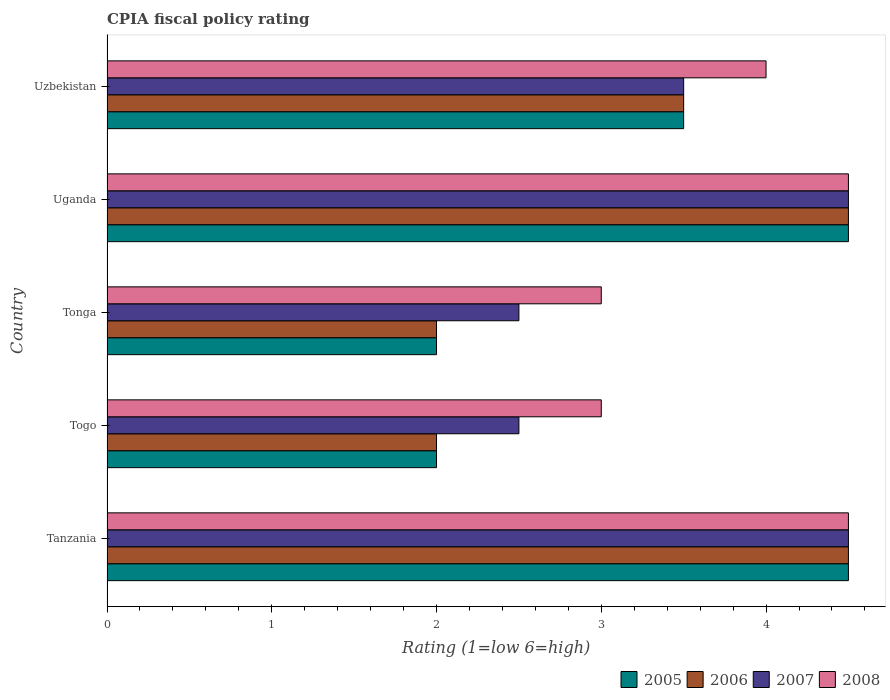How many different coloured bars are there?
Your answer should be very brief. 4. How many groups of bars are there?
Give a very brief answer. 5. Are the number of bars on each tick of the Y-axis equal?
Give a very brief answer. Yes. How many bars are there on the 1st tick from the bottom?
Give a very brief answer. 4. What is the label of the 3rd group of bars from the top?
Offer a terse response. Tonga. In how many cases, is the number of bars for a given country not equal to the number of legend labels?
Ensure brevity in your answer.  0. What is the CPIA rating in 2005 in Tonga?
Keep it short and to the point. 2. In which country was the CPIA rating in 2008 maximum?
Your answer should be very brief. Tanzania. In which country was the CPIA rating in 2008 minimum?
Keep it short and to the point. Togo. What is the average CPIA rating in 2006 per country?
Ensure brevity in your answer.  3.3. What is the difference between the CPIA rating in 2006 and CPIA rating in 2005 in Tanzania?
Offer a very short reply. 0. What is the ratio of the CPIA rating in 2005 in Tanzania to that in Uganda?
Provide a succinct answer. 1. Is the CPIA rating in 2008 in Tonga less than that in Uganda?
Offer a very short reply. Yes. Is the difference between the CPIA rating in 2006 in Togo and Uganda greater than the difference between the CPIA rating in 2005 in Togo and Uganda?
Your response must be concise. No. What is the difference between the highest and the second highest CPIA rating in 2008?
Offer a very short reply. 0. What is the difference between the highest and the lowest CPIA rating in 2006?
Make the answer very short. 2.5. Is it the case that in every country, the sum of the CPIA rating in 2005 and CPIA rating in 2008 is greater than the sum of CPIA rating in 2007 and CPIA rating in 2006?
Keep it short and to the point. No. What does the 1st bar from the top in Uganda represents?
Offer a terse response. 2008. Is it the case that in every country, the sum of the CPIA rating in 2007 and CPIA rating in 2006 is greater than the CPIA rating in 2005?
Your response must be concise. Yes. Where does the legend appear in the graph?
Ensure brevity in your answer.  Bottom right. How many legend labels are there?
Your response must be concise. 4. How are the legend labels stacked?
Make the answer very short. Horizontal. What is the title of the graph?
Make the answer very short. CPIA fiscal policy rating. Does "1992" appear as one of the legend labels in the graph?
Offer a terse response. No. What is the label or title of the Y-axis?
Make the answer very short. Country. What is the Rating (1=low 6=high) in 2005 in Tanzania?
Make the answer very short. 4.5. What is the Rating (1=low 6=high) in 2008 in Tanzania?
Offer a very short reply. 4.5. What is the Rating (1=low 6=high) of 2005 in Togo?
Your response must be concise. 2. What is the Rating (1=low 6=high) of 2006 in Togo?
Your response must be concise. 2. What is the Rating (1=low 6=high) in 2007 in Togo?
Your response must be concise. 2.5. What is the Rating (1=low 6=high) of 2005 in Tonga?
Give a very brief answer. 2. What is the Rating (1=low 6=high) of 2006 in Tonga?
Keep it short and to the point. 2. What is the Rating (1=low 6=high) in 2007 in Tonga?
Your response must be concise. 2.5. What is the Rating (1=low 6=high) of 2008 in Tonga?
Provide a short and direct response. 3. What is the Rating (1=low 6=high) of 2007 in Uganda?
Ensure brevity in your answer.  4.5. What is the Rating (1=low 6=high) of 2005 in Uzbekistan?
Your answer should be compact. 3.5. What is the Rating (1=low 6=high) in 2007 in Uzbekistan?
Your answer should be compact. 3.5. What is the Rating (1=low 6=high) in 2008 in Uzbekistan?
Ensure brevity in your answer.  4. Across all countries, what is the maximum Rating (1=low 6=high) of 2005?
Ensure brevity in your answer.  4.5. Across all countries, what is the maximum Rating (1=low 6=high) in 2006?
Give a very brief answer. 4.5. Across all countries, what is the maximum Rating (1=low 6=high) of 2008?
Ensure brevity in your answer.  4.5. Across all countries, what is the minimum Rating (1=low 6=high) in 2007?
Provide a succinct answer. 2.5. What is the total Rating (1=low 6=high) of 2005 in the graph?
Make the answer very short. 16.5. What is the total Rating (1=low 6=high) in 2008 in the graph?
Provide a succinct answer. 19. What is the difference between the Rating (1=low 6=high) in 2005 in Tanzania and that in Togo?
Provide a short and direct response. 2.5. What is the difference between the Rating (1=low 6=high) in 2007 in Tanzania and that in Togo?
Your answer should be very brief. 2. What is the difference between the Rating (1=low 6=high) of 2006 in Tanzania and that in Uganda?
Offer a very short reply. 0. What is the difference between the Rating (1=low 6=high) in 2005 in Tanzania and that in Uzbekistan?
Offer a very short reply. 1. What is the difference between the Rating (1=low 6=high) of 2005 in Togo and that in Tonga?
Give a very brief answer. 0. What is the difference between the Rating (1=low 6=high) of 2006 in Togo and that in Tonga?
Ensure brevity in your answer.  0. What is the difference between the Rating (1=low 6=high) of 2007 in Togo and that in Tonga?
Make the answer very short. 0. What is the difference between the Rating (1=low 6=high) of 2005 in Togo and that in Uganda?
Offer a very short reply. -2.5. What is the difference between the Rating (1=low 6=high) in 2006 in Togo and that in Uganda?
Give a very brief answer. -2.5. What is the difference between the Rating (1=low 6=high) of 2005 in Togo and that in Uzbekistan?
Your answer should be very brief. -1.5. What is the difference between the Rating (1=low 6=high) of 2006 in Togo and that in Uzbekistan?
Ensure brevity in your answer.  -1.5. What is the difference between the Rating (1=low 6=high) in 2006 in Tonga and that in Uganda?
Your answer should be compact. -2.5. What is the difference between the Rating (1=low 6=high) of 2007 in Tonga and that in Uganda?
Your answer should be very brief. -2. What is the difference between the Rating (1=low 6=high) of 2005 in Tonga and that in Uzbekistan?
Make the answer very short. -1.5. What is the difference between the Rating (1=low 6=high) in 2006 in Tonga and that in Uzbekistan?
Give a very brief answer. -1.5. What is the difference between the Rating (1=low 6=high) of 2005 in Tanzania and the Rating (1=low 6=high) of 2008 in Togo?
Offer a very short reply. 1.5. What is the difference between the Rating (1=low 6=high) of 2006 in Tanzania and the Rating (1=low 6=high) of 2007 in Togo?
Offer a very short reply. 2. What is the difference between the Rating (1=low 6=high) of 2006 in Tanzania and the Rating (1=low 6=high) of 2008 in Togo?
Keep it short and to the point. 1.5. What is the difference between the Rating (1=low 6=high) of 2005 in Tanzania and the Rating (1=low 6=high) of 2006 in Tonga?
Offer a terse response. 2.5. What is the difference between the Rating (1=low 6=high) of 2005 in Tanzania and the Rating (1=low 6=high) of 2008 in Tonga?
Provide a succinct answer. 1.5. What is the difference between the Rating (1=low 6=high) of 2006 in Tanzania and the Rating (1=low 6=high) of 2008 in Tonga?
Keep it short and to the point. 1.5. What is the difference between the Rating (1=low 6=high) of 2007 in Tanzania and the Rating (1=low 6=high) of 2008 in Tonga?
Make the answer very short. 1.5. What is the difference between the Rating (1=low 6=high) in 2005 in Tanzania and the Rating (1=low 6=high) in 2007 in Uganda?
Your response must be concise. 0. What is the difference between the Rating (1=low 6=high) in 2005 in Tanzania and the Rating (1=low 6=high) in 2008 in Uganda?
Give a very brief answer. 0. What is the difference between the Rating (1=low 6=high) in 2006 in Tanzania and the Rating (1=low 6=high) in 2007 in Uganda?
Make the answer very short. 0. What is the difference between the Rating (1=low 6=high) of 2006 in Tanzania and the Rating (1=low 6=high) of 2008 in Uganda?
Ensure brevity in your answer.  0. What is the difference between the Rating (1=low 6=high) of 2007 in Tanzania and the Rating (1=low 6=high) of 2008 in Uganda?
Provide a short and direct response. 0. What is the difference between the Rating (1=low 6=high) of 2005 in Tanzania and the Rating (1=low 6=high) of 2006 in Uzbekistan?
Your answer should be compact. 1. What is the difference between the Rating (1=low 6=high) in 2006 in Tanzania and the Rating (1=low 6=high) in 2008 in Uzbekistan?
Provide a short and direct response. 0.5. What is the difference between the Rating (1=low 6=high) in 2007 in Tanzania and the Rating (1=low 6=high) in 2008 in Uzbekistan?
Make the answer very short. 0.5. What is the difference between the Rating (1=low 6=high) of 2005 in Togo and the Rating (1=low 6=high) of 2006 in Tonga?
Your answer should be compact. 0. What is the difference between the Rating (1=low 6=high) in 2005 in Togo and the Rating (1=low 6=high) in 2007 in Tonga?
Make the answer very short. -0.5. What is the difference between the Rating (1=low 6=high) of 2005 in Togo and the Rating (1=low 6=high) of 2007 in Uganda?
Offer a very short reply. -2.5. What is the difference between the Rating (1=low 6=high) in 2005 in Togo and the Rating (1=low 6=high) in 2008 in Uganda?
Offer a very short reply. -2.5. What is the difference between the Rating (1=low 6=high) of 2006 in Togo and the Rating (1=low 6=high) of 2008 in Uganda?
Offer a very short reply. -2.5. What is the difference between the Rating (1=low 6=high) in 2007 in Togo and the Rating (1=low 6=high) in 2008 in Uganda?
Give a very brief answer. -2. What is the difference between the Rating (1=low 6=high) in 2005 in Togo and the Rating (1=low 6=high) in 2007 in Uzbekistan?
Make the answer very short. -1.5. What is the difference between the Rating (1=low 6=high) of 2007 in Togo and the Rating (1=low 6=high) of 2008 in Uzbekistan?
Your answer should be very brief. -1.5. What is the difference between the Rating (1=low 6=high) in 2005 in Tonga and the Rating (1=low 6=high) in 2007 in Uganda?
Make the answer very short. -2.5. What is the difference between the Rating (1=low 6=high) of 2005 in Tonga and the Rating (1=low 6=high) of 2008 in Uganda?
Keep it short and to the point. -2.5. What is the difference between the Rating (1=low 6=high) of 2006 in Tonga and the Rating (1=low 6=high) of 2007 in Uganda?
Ensure brevity in your answer.  -2.5. What is the difference between the Rating (1=low 6=high) of 2007 in Tonga and the Rating (1=low 6=high) of 2008 in Uganda?
Make the answer very short. -2. What is the difference between the Rating (1=low 6=high) of 2005 in Tonga and the Rating (1=low 6=high) of 2006 in Uzbekistan?
Provide a succinct answer. -1.5. What is the difference between the Rating (1=low 6=high) of 2006 in Tonga and the Rating (1=low 6=high) of 2008 in Uzbekistan?
Keep it short and to the point. -2. What is the difference between the Rating (1=low 6=high) of 2006 in Uganda and the Rating (1=low 6=high) of 2008 in Uzbekistan?
Your answer should be compact. 0.5. What is the average Rating (1=low 6=high) in 2005 per country?
Your response must be concise. 3.3. What is the average Rating (1=low 6=high) of 2007 per country?
Offer a terse response. 3.5. What is the average Rating (1=low 6=high) in 2008 per country?
Ensure brevity in your answer.  3.8. What is the difference between the Rating (1=low 6=high) of 2006 and Rating (1=low 6=high) of 2008 in Tanzania?
Your answer should be compact. 0. What is the difference between the Rating (1=low 6=high) in 2007 and Rating (1=low 6=high) in 2008 in Tanzania?
Offer a terse response. 0. What is the difference between the Rating (1=low 6=high) of 2005 and Rating (1=low 6=high) of 2006 in Togo?
Keep it short and to the point. 0. What is the difference between the Rating (1=low 6=high) of 2005 and Rating (1=low 6=high) of 2008 in Togo?
Give a very brief answer. -1. What is the difference between the Rating (1=low 6=high) of 2006 and Rating (1=low 6=high) of 2008 in Togo?
Keep it short and to the point. -1. What is the difference between the Rating (1=low 6=high) in 2007 and Rating (1=low 6=high) in 2008 in Togo?
Your answer should be compact. -0.5. What is the difference between the Rating (1=low 6=high) in 2005 and Rating (1=low 6=high) in 2007 in Tonga?
Offer a terse response. -0.5. What is the difference between the Rating (1=low 6=high) of 2006 and Rating (1=low 6=high) of 2008 in Tonga?
Offer a terse response. -1. What is the difference between the Rating (1=low 6=high) of 2007 and Rating (1=low 6=high) of 2008 in Tonga?
Keep it short and to the point. -0.5. What is the difference between the Rating (1=low 6=high) in 2005 and Rating (1=low 6=high) in 2007 in Uganda?
Offer a terse response. 0. What is the difference between the Rating (1=low 6=high) in 2006 and Rating (1=low 6=high) in 2008 in Uganda?
Make the answer very short. 0. What is the difference between the Rating (1=low 6=high) in 2007 and Rating (1=low 6=high) in 2008 in Uganda?
Give a very brief answer. 0. What is the difference between the Rating (1=low 6=high) of 2005 and Rating (1=low 6=high) of 2006 in Uzbekistan?
Your answer should be very brief. 0. What is the difference between the Rating (1=low 6=high) of 2005 and Rating (1=low 6=high) of 2008 in Uzbekistan?
Your answer should be very brief. -0.5. What is the difference between the Rating (1=low 6=high) of 2006 and Rating (1=low 6=high) of 2008 in Uzbekistan?
Provide a succinct answer. -0.5. What is the difference between the Rating (1=low 6=high) of 2007 and Rating (1=low 6=high) of 2008 in Uzbekistan?
Your answer should be very brief. -0.5. What is the ratio of the Rating (1=low 6=high) in 2005 in Tanzania to that in Togo?
Your response must be concise. 2.25. What is the ratio of the Rating (1=low 6=high) of 2006 in Tanzania to that in Togo?
Your answer should be compact. 2.25. What is the ratio of the Rating (1=low 6=high) in 2008 in Tanzania to that in Togo?
Make the answer very short. 1.5. What is the ratio of the Rating (1=low 6=high) of 2005 in Tanzania to that in Tonga?
Make the answer very short. 2.25. What is the ratio of the Rating (1=low 6=high) in 2006 in Tanzania to that in Tonga?
Your response must be concise. 2.25. What is the ratio of the Rating (1=low 6=high) in 2007 in Tanzania to that in Tonga?
Provide a succinct answer. 1.8. What is the ratio of the Rating (1=low 6=high) of 2008 in Tanzania to that in Tonga?
Keep it short and to the point. 1.5. What is the ratio of the Rating (1=low 6=high) of 2006 in Tanzania to that in Uganda?
Offer a terse response. 1. What is the ratio of the Rating (1=low 6=high) of 2007 in Tanzania to that in Uganda?
Your answer should be very brief. 1. What is the ratio of the Rating (1=low 6=high) in 2006 in Tanzania to that in Uzbekistan?
Offer a terse response. 1.29. What is the ratio of the Rating (1=low 6=high) in 2007 in Tanzania to that in Uzbekistan?
Provide a short and direct response. 1.29. What is the ratio of the Rating (1=low 6=high) in 2008 in Tanzania to that in Uzbekistan?
Your answer should be very brief. 1.12. What is the ratio of the Rating (1=low 6=high) in 2005 in Togo to that in Uganda?
Make the answer very short. 0.44. What is the ratio of the Rating (1=low 6=high) of 2006 in Togo to that in Uganda?
Provide a short and direct response. 0.44. What is the ratio of the Rating (1=low 6=high) in 2007 in Togo to that in Uganda?
Your answer should be very brief. 0.56. What is the ratio of the Rating (1=low 6=high) in 2008 in Togo to that in Uganda?
Your answer should be very brief. 0.67. What is the ratio of the Rating (1=low 6=high) of 2006 in Togo to that in Uzbekistan?
Make the answer very short. 0.57. What is the ratio of the Rating (1=low 6=high) of 2008 in Togo to that in Uzbekistan?
Your response must be concise. 0.75. What is the ratio of the Rating (1=low 6=high) of 2005 in Tonga to that in Uganda?
Keep it short and to the point. 0.44. What is the ratio of the Rating (1=low 6=high) of 2006 in Tonga to that in Uganda?
Provide a succinct answer. 0.44. What is the ratio of the Rating (1=low 6=high) of 2007 in Tonga to that in Uganda?
Offer a very short reply. 0.56. What is the ratio of the Rating (1=low 6=high) in 2005 in Tonga to that in Uzbekistan?
Keep it short and to the point. 0.57. What is the ratio of the Rating (1=low 6=high) of 2007 in Tonga to that in Uzbekistan?
Give a very brief answer. 0.71. What is the ratio of the Rating (1=low 6=high) in 2006 in Uganda to that in Uzbekistan?
Ensure brevity in your answer.  1.29. What is the ratio of the Rating (1=low 6=high) of 2007 in Uganda to that in Uzbekistan?
Ensure brevity in your answer.  1.29. What is the ratio of the Rating (1=low 6=high) of 2008 in Uganda to that in Uzbekistan?
Ensure brevity in your answer.  1.12. What is the difference between the highest and the second highest Rating (1=low 6=high) in 2006?
Your answer should be compact. 0. What is the difference between the highest and the second highest Rating (1=low 6=high) of 2008?
Make the answer very short. 0. What is the difference between the highest and the lowest Rating (1=low 6=high) in 2006?
Your answer should be compact. 2.5. What is the difference between the highest and the lowest Rating (1=low 6=high) of 2008?
Your answer should be very brief. 1.5. 